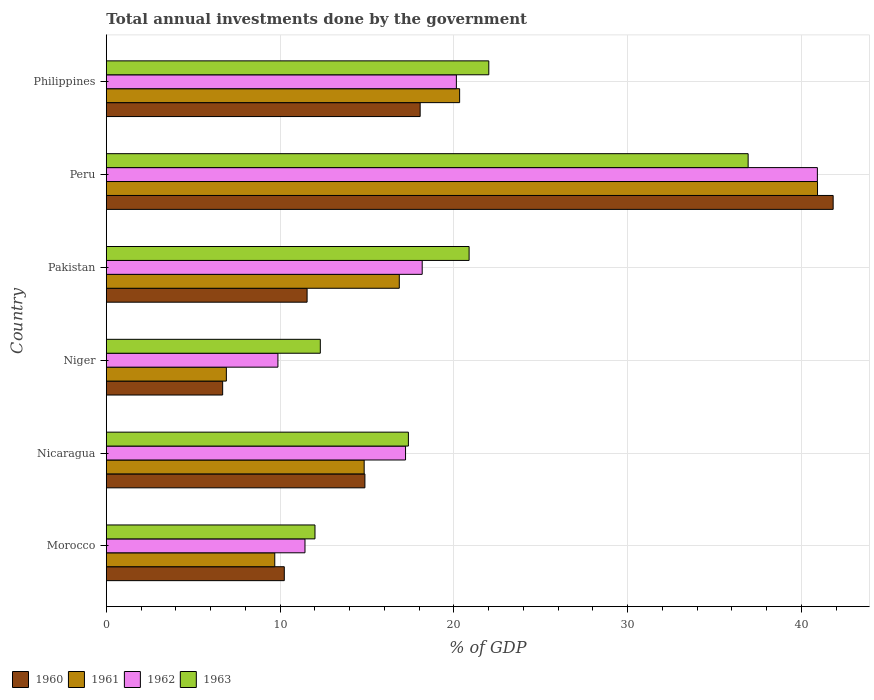How many different coloured bars are there?
Make the answer very short. 4. Are the number of bars per tick equal to the number of legend labels?
Give a very brief answer. Yes. Are the number of bars on each tick of the Y-axis equal?
Your response must be concise. Yes. What is the total annual investments done by the government in 1962 in Nicaragua?
Give a very brief answer. 17.22. Across all countries, what is the maximum total annual investments done by the government in 1963?
Your answer should be compact. 36.94. Across all countries, what is the minimum total annual investments done by the government in 1961?
Offer a terse response. 6.91. In which country was the total annual investments done by the government in 1963 maximum?
Ensure brevity in your answer.  Peru. In which country was the total annual investments done by the government in 1963 minimum?
Your answer should be very brief. Morocco. What is the total total annual investments done by the government in 1962 in the graph?
Offer a terse response. 117.79. What is the difference between the total annual investments done by the government in 1963 in Morocco and that in Nicaragua?
Make the answer very short. -5.38. What is the difference between the total annual investments done by the government in 1963 in Niger and the total annual investments done by the government in 1960 in Nicaragua?
Provide a short and direct response. -2.57. What is the average total annual investments done by the government in 1961 per country?
Your response must be concise. 18.26. What is the difference between the total annual investments done by the government in 1963 and total annual investments done by the government in 1960 in Morocco?
Your answer should be compact. 1.77. What is the ratio of the total annual investments done by the government in 1960 in Niger to that in Philippines?
Ensure brevity in your answer.  0.37. What is the difference between the highest and the second highest total annual investments done by the government in 1963?
Make the answer very short. 14.93. What is the difference between the highest and the lowest total annual investments done by the government in 1962?
Your response must be concise. 31.05. In how many countries, is the total annual investments done by the government in 1961 greater than the average total annual investments done by the government in 1961 taken over all countries?
Provide a short and direct response. 2. Is it the case that in every country, the sum of the total annual investments done by the government in 1962 and total annual investments done by the government in 1961 is greater than the total annual investments done by the government in 1960?
Make the answer very short. Yes. How many countries are there in the graph?
Make the answer very short. 6. Are the values on the major ticks of X-axis written in scientific E-notation?
Your answer should be very brief. No. Where does the legend appear in the graph?
Your answer should be compact. Bottom left. What is the title of the graph?
Your answer should be very brief. Total annual investments done by the government. What is the label or title of the X-axis?
Make the answer very short. % of GDP. What is the % of GDP in 1960 in Morocco?
Ensure brevity in your answer.  10.24. What is the % of GDP in 1961 in Morocco?
Provide a succinct answer. 9.7. What is the % of GDP of 1962 in Morocco?
Offer a very short reply. 11.43. What is the % of GDP of 1963 in Morocco?
Offer a very short reply. 12.01. What is the % of GDP in 1960 in Nicaragua?
Offer a terse response. 14.88. What is the % of GDP in 1961 in Nicaragua?
Ensure brevity in your answer.  14.84. What is the % of GDP in 1962 in Nicaragua?
Provide a short and direct response. 17.22. What is the % of GDP in 1963 in Nicaragua?
Keep it short and to the point. 17.39. What is the % of GDP of 1960 in Niger?
Offer a very short reply. 6.7. What is the % of GDP of 1961 in Niger?
Make the answer very short. 6.91. What is the % of GDP in 1962 in Niger?
Offer a very short reply. 9.88. What is the % of GDP of 1963 in Niger?
Give a very brief answer. 12.32. What is the % of GDP of 1960 in Pakistan?
Give a very brief answer. 11.56. What is the % of GDP in 1961 in Pakistan?
Offer a terse response. 16.86. What is the % of GDP in 1962 in Pakistan?
Your answer should be very brief. 18.18. What is the % of GDP of 1963 in Pakistan?
Give a very brief answer. 20.88. What is the % of GDP of 1960 in Peru?
Keep it short and to the point. 41.84. What is the % of GDP in 1961 in Peru?
Give a very brief answer. 40.94. What is the % of GDP in 1962 in Peru?
Make the answer very short. 40.93. What is the % of GDP in 1963 in Peru?
Offer a terse response. 36.94. What is the % of GDP of 1960 in Philippines?
Offer a terse response. 18.06. What is the % of GDP of 1961 in Philippines?
Make the answer very short. 20.34. What is the % of GDP in 1962 in Philippines?
Your answer should be compact. 20.15. What is the % of GDP in 1963 in Philippines?
Provide a short and direct response. 22.02. Across all countries, what is the maximum % of GDP in 1960?
Provide a succinct answer. 41.84. Across all countries, what is the maximum % of GDP in 1961?
Offer a very short reply. 40.94. Across all countries, what is the maximum % of GDP in 1962?
Keep it short and to the point. 40.93. Across all countries, what is the maximum % of GDP of 1963?
Provide a short and direct response. 36.94. Across all countries, what is the minimum % of GDP of 1960?
Your answer should be compact. 6.7. Across all countries, what is the minimum % of GDP in 1961?
Make the answer very short. 6.91. Across all countries, what is the minimum % of GDP in 1962?
Your answer should be very brief. 9.88. Across all countries, what is the minimum % of GDP of 1963?
Keep it short and to the point. 12.01. What is the total % of GDP in 1960 in the graph?
Your answer should be very brief. 103.28. What is the total % of GDP of 1961 in the graph?
Offer a very short reply. 109.58. What is the total % of GDP of 1962 in the graph?
Provide a succinct answer. 117.79. What is the total % of GDP in 1963 in the graph?
Offer a terse response. 121.55. What is the difference between the % of GDP of 1960 in Morocco and that in Nicaragua?
Offer a very short reply. -4.64. What is the difference between the % of GDP of 1961 in Morocco and that in Nicaragua?
Your response must be concise. -5.15. What is the difference between the % of GDP of 1962 in Morocco and that in Nicaragua?
Your response must be concise. -5.79. What is the difference between the % of GDP of 1963 in Morocco and that in Nicaragua?
Give a very brief answer. -5.38. What is the difference between the % of GDP in 1960 in Morocco and that in Niger?
Ensure brevity in your answer.  3.55. What is the difference between the % of GDP in 1961 in Morocco and that in Niger?
Ensure brevity in your answer.  2.79. What is the difference between the % of GDP in 1962 in Morocco and that in Niger?
Your answer should be compact. 1.56. What is the difference between the % of GDP of 1963 in Morocco and that in Niger?
Ensure brevity in your answer.  -0.31. What is the difference between the % of GDP in 1960 in Morocco and that in Pakistan?
Offer a very short reply. -1.31. What is the difference between the % of GDP in 1961 in Morocco and that in Pakistan?
Your answer should be compact. -7.17. What is the difference between the % of GDP in 1962 in Morocco and that in Pakistan?
Your answer should be compact. -6.75. What is the difference between the % of GDP of 1963 in Morocco and that in Pakistan?
Make the answer very short. -8.87. What is the difference between the % of GDP of 1960 in Morocco and that in Peru?
Ensure brevity in your answer.  -31.59. What is the difference between the % of GDP of 1961 in Morocco and that in Peru?
Offer a terse response. -31.24. What is the difference between the % of GDP of 1962 in Morocco and that in Peru?
Make the answer very short. -29.49. What is the difference between the % of GDP of 1963 in Morocco and that in Peru?
Give a very brief answer. -24.93. What is the difference between the % of GDP of 1960 in Morocco and that in Philippines?
Offer a very short reply. -7.82. What is the difference between the % of GDP in 1961 in Morocco and that in Philippines?
Offer a very short reply. -10.64. What is the difference between the % of GDP in 1962 in Morocco and that in Philippines?
Offer a terse response. -8.71. What is the difference between the % of GDP of 1963 in Morocco and that in Philippines?
Keep it short and to the point. -10. What is the difference between the % of GDP in 1960 in Nicaragua and that in Niger?
Provide a succinct answer. 8.19. What is the difference between the % of GDP of 1961 in Nicaragua and that in Niger?
Make the answer very short. 7.93. What is the difference between the % of GDP of 1962 in Nicaragua and that in Niger?
Offer a very short reply. 7.35. What is the difference between the % of GDP of 1963 in Nicaragua and that in Niger?
Provide a succinct answer. 5.07. What is the difference between the % of GDP in 1960 in Nicaragua and that in Pakistan?
Your answer should be very brief. 3.33. What is the difference between the % of GDP in 1961 in Nicaragua and that in Pakistan?
Give a very brief answer. -2.02. What is the difference between the % of GDP of 1962 in Nicaragua and that in Pakistan?
Give a very brief answer. -0.96. What is the difference between the % of GDP in 1963 in Nicaragua and that in Pakistan?
Provide a short and direct response. -3.5. What is the difference between the % of GDP of 1960 in Nicaragua and that in Peru?
Ensure brevity in your answer.  -26.95. What is the difference between the % of GDP in 1961 in Nicaragua and that in Peru?
Offer a very short reply. -26.1. What is the difference between the % of GDP in 1962 in Nicaragua and that in Peru?
Keep it short and to the point. -23.7. What is the difference between the % of GDP of 1963 in Nicaragua and that in Peru?
Your answer should be compact. -19.56. What is the difference between the % of GDP of 1960 in Nicaragua and that in Philippines?
Ensure brevity in your answer.  -3.18. What is the difference between the % of GDP of 1961 in Nicaragua and that in Philippines?
Provide a succinct answer. -5.49. What is the difference between the % of GDP in 1962 in Nicaragua and that in Philippines?
Give a very brief answer. -2.93. What is the difference between the % of GDP of 1963 in Nicaragua and that in Philippines?
Your answer should be very brief. -4.63. What is the difference between the % of GDP in 1960 in Niger and that in Pakistan?
Your response must be concise. -4.86. What is the difference between the % of GDP of 1961 in Niger and that in Pakistan?
Keep it short and to the point. -9.95. What is the difference between the % of GDP in 1962 in Niger and that in Pakistan?
Ensure brevity in your answer.  -8.3. What is the difference between the % of GDP in 1963 in Niger and that in Pakistan?
Provide a short and direct response. -8.57. What is the difference between the % of GDP in 1960 in Niger and that in Peru?
Keep it short and to the point. -35.14. What is the difference between the % of GDP of 1961 in Niger and that in Peru?
Your answer should be very brief. -34.03. What is the difference between the % of GDP in 1962 in Niger and that in Peru?
Offer a terse response. -31.05. What is the difference between the % of GDP of 1963 in Niger and that in Peru?
Your answer should be compact. -24.63. What is the difference between the % of GDP in 1960 in Niger and that in Philippines?
Give a very brief answer. -11.37. What is the difference between the % of GDP in 1961 in Niger and that in Philippines?
Your response must be concise. -13.43. What is the difference between the % of GDP in 1962 in Niger and that in Philippines?
Make the answer very short. -10.27. What is the difference between the % of GDP in 1963 in Niger and that in Philippines?
Offer a terse response. -9.7. What is the difference between the % of GDP in 1960 in Pakistan and that in Peru?
Your response must be concise. -30.28. What is the difference between the % of GDP of 1961 in Pakistan and that in Peru?
Your answer should be compact. -24.07. What is the difference between the % of GDP in 1962 in Pakistan and that in Peru?
Make the answer very short. -22.75. What is the difference between the % of GDP in 1963 in Pakistan and that in Peru?
Provide a short and direct response. -16.06. What is the difference between the % of GDP of 1960 in Pakistan and that in Philippines?
Provide a succinct answer. -6.51. What is the difference between the % of GDP of 1961 in Pakistan and that in Philippines?
Your answer should be compact. -3.47. What is the difference between the % of GDP in 1962 in Pakistan and that in Philippines?
Your response must be concise. -1.97. What is the difference between the % of GDP in 1963 in Pakistan and that in Philippines?
Your answer should be very brief. -1.13. What is the difference between the % of GDP in 1960 in Peru and that in Philippines?
Your answer should be compact. 23.77. What is the difference between the % of GDP of 1961 in Peru and that in Philippines?
Keep it short and to the point. 20.6. What is the difference between the % of GDP of 1962 in Peru and that in Philippines?
Your answer should be very brief. 20.78. What is the difference between the % of GDP of 1963 in Peru and that in Philippines?
Provide a short and direct response. 14.93. What is the difference between the % of GDP of 1960 in Morocco and the % of GDP of 1961 in Nicaragua?
Offer a terse response. -4.6. What is the difference between the % of GDP in 1960 in Morocco and the % of GDP in 1962 in Nicaragua?
Your response must be concise. -6.98. What is the difference between the % of GDP of 1960 in Morocco and the % of GDP of 1963 in Nicaragua?
Provide a short and direct response. -7.14. What is the difference between the % of GDP in 1961 in Morocco and the % of GDP in 1962 in Nicaragua?
Your response must be concise. -7.53. What is the difference between the % of GDP in 1961 in Morocco and the % of GDP in 1963 in Nicaragua?
Provide a short and direct response. -7.69. What is the difference between the % of GDP in 1962 in Morocco and the % of GDP in 1963 in Nicaragua?
Provide a short and direct response. -5.95. What is the difference between the % of GDP of 1960 in Morocco and the % of GDP of 1961 in Niger?
Your answer should be very brief. 3.33. What is the difference between the % of GDP in 1960 in Morocco and the % of GDP in 1962 in Niger?
Offer a terse response. 0.37. What is the difference between the % of GDP in 1960 in Morocco and the % of GDP in 1963 in Niger?
Your response must be concise. -2.07. What is the difference between the % of GDP of 1961 in Morocco and the % of GDP of 1962 in Niger?
Make the answer very short. -0.18. What is the difference between the % of GDP of 1961 in Morocco and the % of GDP of 1963 in Niger?
Your response must be concise. -2.62. What is the difference between the % of GDP of 1962 in Morocco and the % of GDP of 1963 in Niger?
Ensure brevity in your answer.  -0.88. What is the difference between the % of GDP of 1960 in Morocco and the % of GDP of 1961 in Pakistan?
Your response must be concise. -6.62. What is the difference between the % of GDP of 1960 in Morocco and the % of GDP of 1962 in Pakistan?
Your answer should be very brief. -7.94. What is the difference between the % of GDP of 1960 in Morocco and the % of GDP of 1963 in Pakistan?
Ensure brevity in your answer.  -10.64. What is the difference between the % of GDP of 1961 in Morocco and the % of GDP of 1962 in Pakistan?
Offer a very short reply. -8.49. What is the difference between the % of GDP of 1961 in Morocco and the % of GDP of 1963 in Pakistan?
Offer a very short reply. -11.19. What is the difference between the % of GDP of 1962 in Morocco and the % of GDP of 1963 in Pakistan?
Ensure brevity in your answer.  -9.45. What is the difference between the % of GDP of 1960 in Morocco and the % of GDP of 1961 in Peru?
Ensure brevity in your answer.  -30.69. What is the difference between the % of GDP of 1960 in Morocco and the % of GDP of 1962 in Peru?
Offer a very short reply. -30.68. What is the difference between the % of GDP of 1960 in Morocco and the % of GDP of 1963 in Peru?
Ensure brevity in your answer.  -26.7. What is the difference between the % of GDP of 1961 in Morocco and the % of GDP of 1962 in Peru?
Provide a short and direct response. -31.23. What is the difference between the % of GDP in 1961 in Morocco and the % of GDP in 1963 in Peru?
Make the answer very short. -27.25. What is the difference between the % of GDP in 1962 in Morocco and the % of GDP in 1963 in Peru?
Give a very brief answer. -25.51. What is the difference between the % of GDP of 1960 in Morocco and the % of GDP of 1961 in Philippines?
Ensure brevity in your answer.  -10.09. What is the difference between the % of GDP of 1960 in Morocco and the % of GDP of 1962 in Philippines?
Your response must be concise. -9.91. What is the difference between the % of GDP in 1960 in Morocco and the % of GDP in 1963 in Philippines?
Offer a terse response. -11.77. What is the difference between the % of GDP in 1961 in Morocco and the % of GDP in 1962 in Philippines?
Give a very brief answer. -10.45. What is the difference between the % of GDP in 1961 in Morocco and the % of GDP in 1963 in Philippines?
Provide a succinct answer. -12.32. What is the difference between the % of GDP in 1962 in Morocco and the % of GDP in 1963 in Philippines?
Your answer should be very brief. -10.58. What is the difference between the % of GDP of 1960 in Nicaragua and the % of GDP of 1961 in Niger?
Offer a terse response. 7.97. What is the difference between the % of GDP of 1960 in Nicaragua and the % of GDP of 1962 in Niger?
Provide a succinct answer. 5.01. What is the difference between the % of GDP in 1960 in Nicaragua and the % of GDP in 1963 in Niger?
Your answer should be compact. 2.57. What is the difference between the % of GDP in 1961 in Nicaragua and the % of GDP in 1962 in Niger?
Provide a short and direct response. 4.96. What is the difference between the % of GDP of 1961 in Nicaragua and the % of GDP of 1963 in Niger?
Your answer should be very brief. 2.52. What is the difference between the % of GDP in 1962 in Nicaragua and the % of GDP in 1963 in Niger?
Provide a succinct answer. 4.91. What is the difference between the % of GDP of 1960 in Nicaragua and the % of GDP of 1961 in Pakistan?
Offer a very short reply. -1.98. What is the difference between the % of GDP of 1960 in Nicaragua and the % of GDP of 1962 in Pakistan?
Provide a short and direct response. -3.3. What is the difference between the % of GDP of 1960 in Nicaragua and the % of GDP of 1963 in Pakistan?
Provide a short and direct response. -6. What is the difference between the % of GDP in 1961 in Nicaragua and the % of GDP in 1962 in Pakistan?
Give a very brief answer. -3.34. What is the difference between the % of GDP in 1961 in Nicaragua and the % of GDP in 1963 in Pakistan?
Your response must be concise. -6.04. What is the difference between the % of GDP in 1962 in Nicaragua and the % of GDP in 1963 in Pakistan?
Give a very brief answer. -3.66. What is the difference between the % of GDP in 1960 in Nicaragua and the % of GDP in 1961 in Peru?
Give a very brief answer. -26.05. What is the difference between the % of GDP in 1960 in Nicaragua and the % of GDP in 1962 in Peru?
Provide a short and direct response. -26.04. What is the difference between the % of GDP of 1960 in Nicaragua and the % of GDP of 1963 in Peru?
Your answer should be very brief. -22.06. What is the difference between the % of GDP in 1961 in Nicaragua and the % of GDP in 1962 in Peru?
Ensure brevity in your answer.  -26.09. What is the difference between the % of GDP in 1961 in Nicaragua and the % of GDP in 1963 in Peru?
Your answer should be compact. -22.1. What is the difference between the % of GDP in 1962 in Nicaragua and the % of GDP in 1963 in Peru?
Offer a very short reply. -19.72. What is the difference between the % of GDP of 1960 in Nicaragua and the % of GDP of 1961 in Philippines?
Offer a very short reply. -5.45. What is the difference between the % of GDP of 1960 in Nicaragua and the % of GDP of 1962 in Philippines?
Give a very brief answer. -5.27. What is the difference between the % of GDP of 1960 in Nicaragua and the % of GDP of 1963 in Philippines?
Your answer should be very brief. -7.13. What is the difference between the % of GDP in 1961 in Nicaragua and the % of GDP in 1962 in Philippines?
Offer a very short reply. -5.31. What is the difference between the % of GDP of 1961 in Nicaragua and the % of GDP of 1963 in Philippines?
Ensure brevity in your answer.  -7.17. What is the difference between the % of GDP in 1962 in Nicaragua and the % of GDP in 1963 in Philippines?
Your response must be concise. -4.79. What is the difference between the % of GDP in 1960 in Niger and the % of GDP in 1961 in Pakistan?
Your answer should be compact. -10.17. What is the difference between the % of GDP in 1960 in Niger and the % of GDP in 1962 in Pakistan?
Offer a terse response. -11.49. What is the difference between the % of GDP in 1960 in Niger and the % of GDP in 1963 in Pakistan?
Provide a short and direct response. -14.19. What is the difference between the % of GDP of 1961 in Niger and the % of GDP of 1962 in Pakistan?
Give a very brief answer. -11.27. What is the difference between the % of GDP of 1961 in Niger and the % of GDP of 1963 in Pakistan?
Offer a very short reply. -13.97. What is the difference between the % of GDP in 1962 in Niger and the % of GDP in 1963 in Pakistan?
Provide a short and direct response. -11. What is the difference between the % of GDP in 1960 in Niger and the % of GDP in 1961 in Peru?
Ensure brevity in your answer.  -34.24. What is the difference between the % of GDP of 1960 in Niger and the % of GDP of 1962 in Peru?
Provide a short and direct response. -34.23. What is the difference between the % of GDP of 1960 in Niger and the % of GDP of 1963 in Peru?
Make the answer very short. -30.25. What is the difference between the % of GDP of 1961 in Niger and the % of GDP of 1962 in Peru?
Your answer should be compact. -34.02. What is the difference between the % of GDP in 1961 in Niger and the % of GDP in 1963 in Peru?
Offer a very short reply. -30.03. What is the difference between the % of GDP of 1962 in Niger and the % of GDP of 1963 in Peru?
Offer a very short reply. -27.07. What is the difference between the % of GDP in 1960 in Niger and the % of GDP in 1961 in Philippines?
Ensure brevity in your answer.  -13.64. What is the difference between the % of GDP in 1960 in Niger and the % of GDP in 1962 in Philippines?
Give a very brief answer. -13.45. What is the difference between the % of GDP of 1960 in Niger and the % of GDP of 1963 in Philippines?
Provide a succinct answer. -15.32. What is the difference between the % of GDP of 1961 in Niger and the % of GDP of 1962 in Philippines?
Ensure brevity in your answer.  -13.24. What is the difference between the % of GDP in 1961 in Niger and the % of GDP in 1963 in Philippines?
Provide a succinct answer. -15.11. What is the difference between the % of GDP of 1962 in Niger and the % of GDP of 1963 in Philippines?
Keep it short and to the point. -12.14. What is the difference between the % of GDP of 1960 in Pakistan and the % of GDP of 1961 in Peru?
Give a very brief answer. -29.38. What is the difference between the % of GDP in 1960 in Pakistan and the % of GDP in 1962 in Peru?
Your answer should be compact. -29.37. What is the difference between the % of GDP of 1960 in Pakistan and the % of GDP of 1963 in Peru?
Provide a short and direct response. -25.39. What is the difference between the % of GDP in 1961 in Pakistan and the % of GDP in 1962 in Peru?
Make the answer very short. -24.06. What is the difference between the % of GDP in 1961 in Pakistan and the % of GDP in 1963 in Peru?
Give a very brief answer. -20.08. What is the difference between the % of GDP in 1962 in Pakistan and the % of GDP in 1963 in Peru?
Ensure brevity in your answer.  -18.76. What is the difference between the % of GDP of 1960 in Pakistan and the % of GDP of 1961 in Philippines?
Provide a succinct answer. -8.78. What is the difference between the % of GDP in 1960 in Pakistan and the % of GDP in 1962 in Philippines?
Offer a very short reply. -8.59. What is the difference between the % of GDP of 1960 in Pakistan and the % of GDP of 1963 in Philippines?
Your response must be concise. -10.46. What is the difference between the % of GDP of 1961 in Pakistan and the % of GDP of 1962 in Philippines?
Keep it short and to the point. -3.29. What is the difference between the % of GDP of 1961 in Pakistan and the % of GDP of 1963 in Philippines?
Your response must be concise. -5.15. What is the difference between the % of GDP in 1962 in Pakistan and the % of GDP in 1963 in Philippines?
Your answer should be compact. -3.83. What is the difference between the % of GDP of 1960 in Peru and the % of GDP of 1961 in Philippines?
Your answer should be compact. 21.5. What is the difference between the % of GDP in 1960 in Peru and the % of GDP in 1962 in Philippines?
Your response must be concise. 21.69. What is the difference between the % of GDP of 1960 in Peru and the % of GDP of 1963 in Philippines?
Make the answer very short. 19.82. What is the difference between the % of GDP of 1961 in Peru and the % of GDP of 1962 in Philippines?
Keep it short and to the point. 20.79. What is the difference between the % of GDP in 1961 in Peru and the % of GDP in 1963 in Philippines?
Your response must be concise. 18.92. What is the difference between the % of GDP in 1962 in Peru and the % of GDP in 1963 in Philippines?
Your answer should be compact. 18.91. What is the average % of GDP in 1960 per country?
Offer a very short reply. 17.21. What is the average % of GDP in 1961 per country?
Your answer should be compact. 18.26. What is the average % of GDP in 1962 per country?
Give a very brief answer. 19.63. What is the average % of GDP of 1963 per country?
Keep it short and to the point. 20.26. What is the difference between the % of GDP of 1960 and % of GDP of 1961 in Morocco?
Your response must be concise. 0.55. What is the difference between the % of GDP of 1960 and % of GDP of 1962 in Morocco?
Make the answer very short. -1.19. What is the difference between the % of GDP in 1960 and % of GDP in 1963 in Morocco?
Offer a very short reply. -1.77. What is the difference between the % of GDP in 1961 and % of GDP in 1962 in Morocco?
Your answer should be very brief. -1.74. What is the difference between the % of GDP of 1961 and % of GDP of 1963 in Morocco?
Provide a succinct answer. -2.32. What is the difference between the % of GDP of 1962 and % of GDP of 1963 in Morocco?
Your answer should be very brief. -0.58. What is the difference between the % of GDP of 1960 and % of GDP of 1961 in Nicaragua?
Your response must be concise. 0.04. What is the difference between the % of GDP of 1960 and % of GDP of 1962 in Nicaragua?
Offer a very short reply. -2.34. What is the difference between the % of GDP in 1960 and % of GDP in 1963 in Nicaragua?
Your answer should be compact. -2.5. What is the difference between the % of GDP in 1961 and % of GDP in 1962 in Nicaragua?
Ensure brevity in your answer.  -2.38. What is the difference between the % of GDP in 1961 and % of GDP in 1963 in Nicaragua?
Provide a short and direct response. -2.55. What is the difference between the % of GDP in 1962 and % of GDP in 1963 in Nicaragua?
Keep it short and to the point. -0.16. What is the difference between the % of GDP in 1960 and % of GDP in 1961 in Niger?
Keep it short and to the point. -0.21. What is the difference between the % of GDP in 1960 and % of GDP in 1962 in Niger?
Provide a succinct answer. -3.18. What is the difference between the % of GDP of 1960 and % of GDP of 1963 in Niger?
Give a very brief answer. -5.62. What is the difference between the % of GDP in 1961 and % of GDP in 1962 in Niger?
Offer a terse response. -2.97. What is the difference between the % of GDP in 1961 and % of GDP in 1963 in Niger?
Keep it short and to the point. -5.41. What is the difference between the % of GDP of 1962 and % of GDP of 1963 in Niger?
Keep it short and to the point. -2.44. What is the difference between the % of GDP of 1960 and % of GDP of 1961 in Pakistan?
Ensure brevity in your answer.  -5.31. What is the difference between the % of GDP of 1960 and % of GDP of 1962 in Pakistan?
Offer a very short reply. -6.63. What is the difference between the % of GDP in 1960 and % of GDP in 1963 in Pakistan?
Provide a short and direct response. -9.33. What is the difference between the % of GDP of 1961 and % of GDP of 1962 in Pakistan?
Give a very brief answer. -1.32. What is the difference between the % of GDP of 1961 and % of GDP of 1963 in Pakistan?
Your response must be concise. -4.02. What is the difference between the % of GDP of 1962 and % of GDP of 1963 in Pakistan?
Make the answer very short. -2.7. What is the difference between the % of GDP of 1960 and % of GDP of 1961 in Peru?
Keep it short and to the point. 0.9. What is the difference between the % of GDP in 1960 and % of GDP in 1962 in Peru?
Keep it short and to the point. 0.91. What is the difference between the % of GDP in 1960 and % of GDP in 1963 in Peru?
Offer a very short reply. 4.89. What is the difference between the % of GDP in 1961 and % of GDP in 1962 in Peru?
Give a very brief answer. 0.01. What is the difference between the % of GDP of 1961 and % of GDP of 1963 in Peru?
Your answer should be compact. 3.99. What is the difference between the % of GDP in 1962 and % of GDP in 1963 in Peru?
Your answer should be compact. 3.99. What is the difference between the % of GDP of 1960 and % of GDP of 1961 in Philippines?
Offer a terse response. -2.27. What is the difference between the % of GDP in 1960 and % of GDP in 1962 in Philippines?
Provide a succinct answer. -2.09. What is the difference between the % of GDP in 1960 and % of GDP in 1963 in Philippines?
Your answer should be very brief. -3.95. What is the difference between the % of GDP of 1961 and % of GDP of 1962 in Philippines?
Provide a succinct answer. 0.19. What is the difference between the % of GDP of 1961 and % of GDP of 1963 in Philippines?
Keep it short and to the point. -1.68. What is the difference between the % of GDP of 1962 and % of GDP of 1963 in Philippines?
Offer a terse response. -1.87. What is the ratio of the % of GDP of 1960 in Morocco to that in Nicaragua?
Your response must be concise. 0.69. What is the ratio of the % of GDP of 1961 in Morocco to that in Nicaragua?
Offer a terse response. 0.65. What is the ratio of the % of GDP of 1962 in Morocco to that in Nicaragua?
Ensure brevity in your answer.  0.66. What is the ratio of the % of GDP in 1963 in Morocco to that in Nicaragua?
Provide a succinct answer. 0.69. What is the ratio of the % of GDP in 1960 in Morocco to that in Niger?
Give a very brief answer. 1.53. What is the ratio of the % of GDP of 1961 in Morocco to that in Niger?
Give a very brief answer. 1.4. What is the ratio of the % of GDP in 1962 in Morocco to that in Niger?
Your answer should be compact. 1.16. What is the ratio of the % of GDP of 1963 in Morocco to that in Niger?
Give a very brief answer. 0.98. What is the ratio of the % of GDP of 1960 in Morocco to that in Pakistan?
Offer a very short reply. 0.89. What is the ratio of the % of GDP in 1961 in Morocco to that in Pakistan?
Provide a succinct answer. 0.57. What is the ratio of the % of GDP of 1962 in Morocco to that in Pakistan?
Provide a short and direct response. 0.63. What is the ratio of the % of GDP in 1963 in Morocco to that in Pakistan?
Give a very brief answer. 0.58. What is the ratio of the % of GDP in 1960 in Morocco to that in Peru?
Make the answer very short. 0.24. What is the ratio of the % of GDP of 1961 in Morocco to that in Peru?
Your answer should be compact. 0.24. What is the ratio of the % of GDP of 1962 in Morocco to that in Peru?
Your answer should be compact. 0.28. What is the ratio of the % of GDP of 1963 in Morocco to that in Peru?
Ensure brevity in your answer.  0.33. What is the ratio of the % of GDP of 1960 in Morocco to that in Philippines?
Ensure brevity in your answer.  0.57. What is the ratio of the % of GDP in 1961 in Morocco to that in Philippines?
Offer a very short reply. 0.48. What is the ratio of the % of GDP in 1962 in Morocco to that in Philippines?
Provide a succinct answer. 0.57. What is the ratio of the % of GDP of 1963 in Morocco to that in Philippines?
Ensure brevity in your answer.  0.55. What is the ratio of the % of GDP of 1960 in Nicaragua to that in Niger?
Give a very brief answer. 2.22. What is the ratio of the % of GDP in 1961 in Nicaragua to that in Niger?
Ensure brevity in your answer.  2.15. What is the ratio of the % of GDP in 1962 in Nicaragua to that in Niger?
Ensure brevity in your answer.  1.74. What is the ratio of the % of GDP in 1963 in Nicaragua to that in Niger?
Your response must be concise. 1.41. What is the ratio of the % of GDP of 1960 in Nicaragua to that in Pakistan?
Make the answer very short. 1.29. What is the ratio of the % of GDP of 1961 in Nicaragua to that in Pakistan?
Your answer should be compact. 0.88. What is the ratio of the % of GDP in 1962 in Nicaragua to that in Pakistan?
Offer a terse response. 0.95. What is the ratio of the % of GDP of 1963 in Nicaragua to that in Pakistan?
Your response must be concise. 0.83. What is the ratio of the % of GDP of 1960 in Nicaragua to that in Peru?
Provide a succinct answer. 0.36. What is the ratio of the % of GDP of 1961 in Nicaragua to that in Peru?
Make the answer very short. 0.36. What is the ratio of the % of GDP of 1962 in Nicaragua to that in Peru?
Provide a short and direct response. 0.42. What is the ratio of the % of GDP of 1963 in Nicaragua to that in Peru?
Your answer should be very brief. 0.47. What is the ratio of the % of GDP of 1960 in Nicaragua to that in Philippines?
Offer a very short reply. 0.82. What is the ratio of the % of GDP in 1961 in Nicaragua to that in Philippines?
Your answer should be compact. 0.73. What is the ratio of the % of GDP of 1962 in Nicaragua to that in Philippines?
Offer a terse response. 0.85. What is the ratio of the % of GDP in 1963 in Nicaragua to that in Philippines?
Your answer should be compact. 0.79. What is the ratio of the % of GDP in 1960 in Niger to that in Pakistan?
Offer a terse response. 0.58. What is the ratio of the % of GDP of 1961 in Niger to that in Pakistan?
Make the answer very short. 0.41. What is the ratio of the % of GDP of 1962 in Niger to that in Pakistan?
Make the answer very short. 0.54. What is the ratio of the % of GDP in 1963 in Niger to that in Pakistan?
Your answer should be very brief. 0.59. What is the ratio of the % of GDP of 1960 in Niger to that in Peru?
Keep it short and to the point. 0.16. What is the ratio of the % of GDP in 1961 in Niger to that in Peru?
Provide a succinct answer. 0.17. What is the ratio of the % of GDP of 1962 in Niger to that in Peru?
Keep it short and to the point. 0.24. What is the ratio of the % of GDP in 1963 in Niger to that in Peru?
Give a very brief answer. 0.33. What is the ratio of the % of GDP in 1960 in Niger to that in Philippines?
Ensure brevity in your answer.  0.37. What is the ratio of the % of GDP of 1961 in Niger to that in Philippines?
Offer a terse response. 0.34. What is the ratio of the % of GDP in 1962 in Niger to that in Philippines?
Make the answer very short. 0.49. What is the ratio of the % of GDP in 1963 in Niger to that in Philippines?
Offer a terse response. 0.56. What is the ratio of the % of GDP in 1960 in Pakistan to that in Peru?
Offer a terse response. 0.28. What is the ratio of the % of GDP of 1961 in Pakistan to that in Peru?
Offer a terse response. 0.41. What is the ratio of the % of GDP of 1962 in Pakistan to that in Peru?
Your response must be concise. 0.44. What is the ratio of the % of GDP of 1963 in Pakistan to that in Peru?
Your response must be concise. 0.57. What is the ratio of the % of GDP of 1960 in Pakistan to that in Philippines?
Make the answer very short. 0.64. What is the ratio of the % of GDP in 1961 in Pakistan to that in Philippines?
Keep it short and to the point. 0.83. What is the ratio of the % of GDP of 1962 in Pakistan to that in Philippines?
Your answer should be compact. 0.9. What is the ratio of the % of GDP of 1963 in Pakistan to that in Philippines?
Keep it short and to the point. 0.95. What is the ratio of the % of GDP of 1960 in Peru to that in Philippines?
Make the answer very short. 2.32. What is the ratio of the % of GDP of 1961 in Peru to that in Philippines?
Make the answer very short. 2.01. What is the ratio of the % of GDP in 1962 in Peru to that in Philippines?
Provide a succinct answer. 2.03. What is the ratio of the % of GDP in 1963 in Peru to that in Philippines?
Offer a terse response. 1.68. What is the difference between the highest and the second highest % of GDP in 1960?
Your answer should be compact. 23.77. What is the difference between the highest and the second highest % of GDP of 1961?
Offer a very short reply. 20.6. What is the difference between the highest and the second highest % of GDP in 1962?
Give a very brief answer. 20.78. What is the difference between the highest and the second highest % of GDP in 1963?
Your answer should be compact. 14.93. What is the difference between the highest and the lowest % of GDP of 1960?
Offer a terse response. 35.14. What is the difference between the highest and the lowest % of GDP of 1961?
Provide a succinct answer. 34.03. What is the difference between the highest and the lowest % of GDP in 1962?
Keep it short and to the point. 31.05. What is the difference between the highest and the lowest % of GDP of 1963?
Provide a succinct answer. 24.93. 